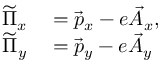<formula> <loc_0><loc_0><loc_500><loc_500>\begin{array} { r l } { \widetilde { \Pi } _ { x } } & = \vec { p } _ { x } - e \vec { A } _ { x } , } \\ { \widetilde { \Pi } _ { y } } & = \vec { p } _ { y } - e \vec { A } _ { y } } \end{array}</formula> 